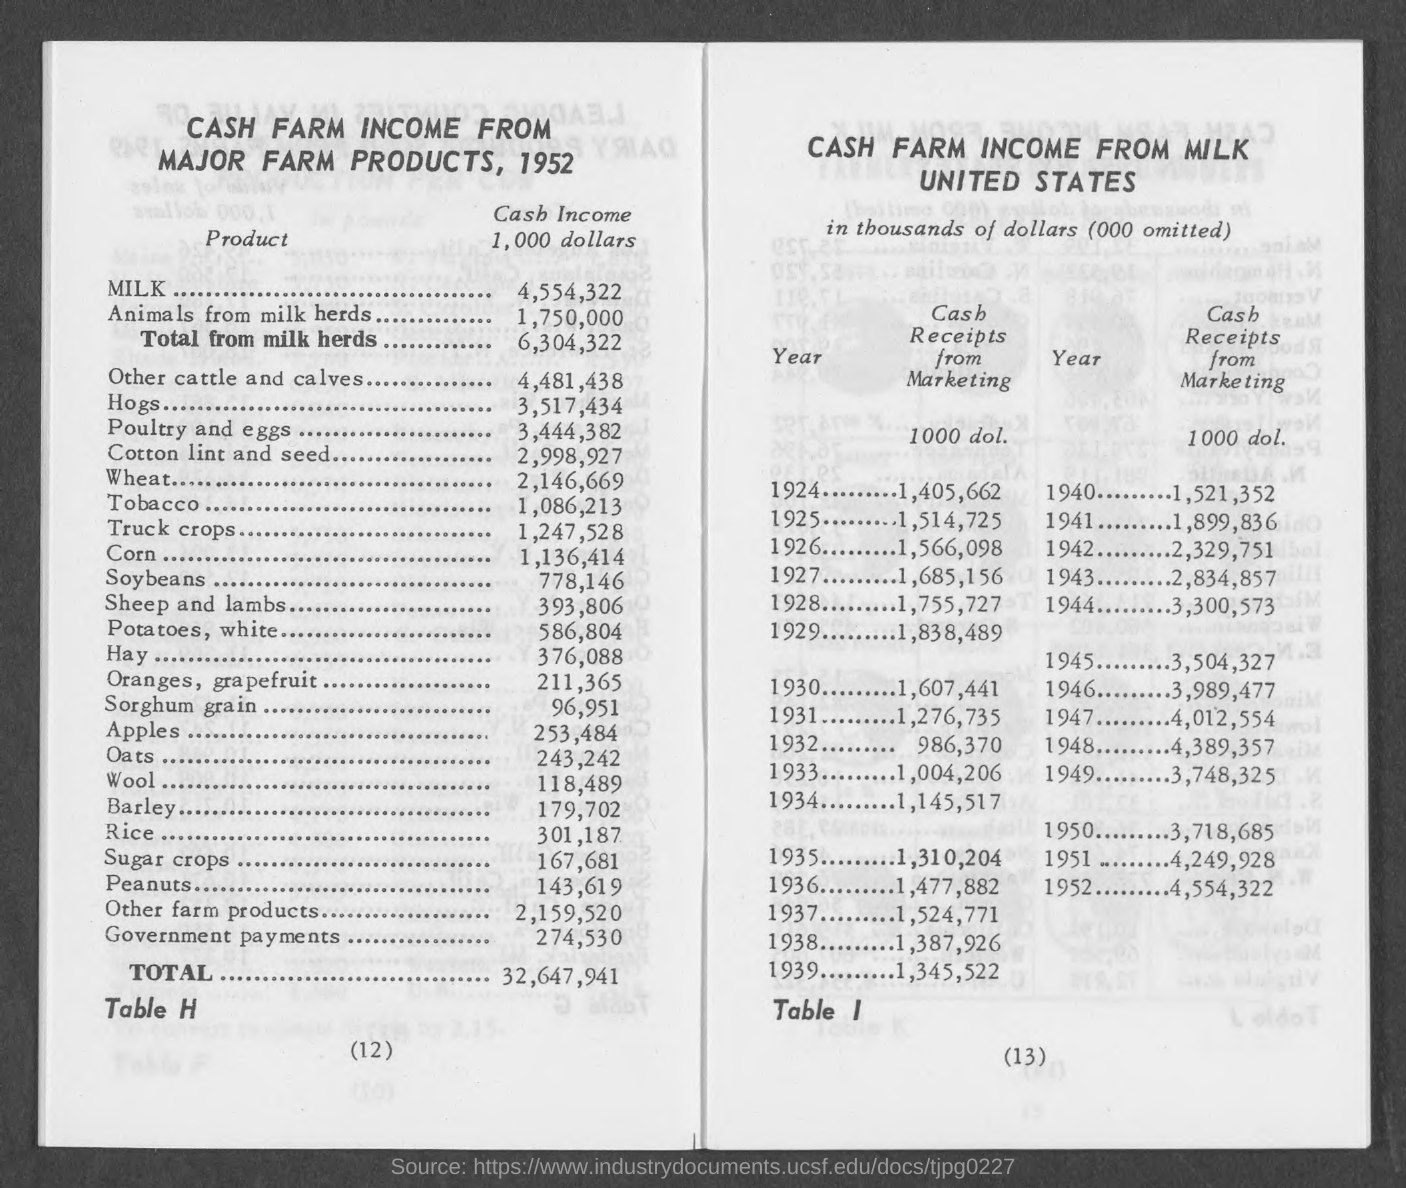Identify some key points in this picture. The amount of cash income of apples mentioned in the given page is 253,484. The amount of cash income of tobacco mentioned in the given page is 1,086,213. The amount of cash income for milk mentioned in the given page is 4,554,322. The amount of total cash income mentioned in the given page is 32,647,941. The amount of cash income generated by corn is 1,136,414. 